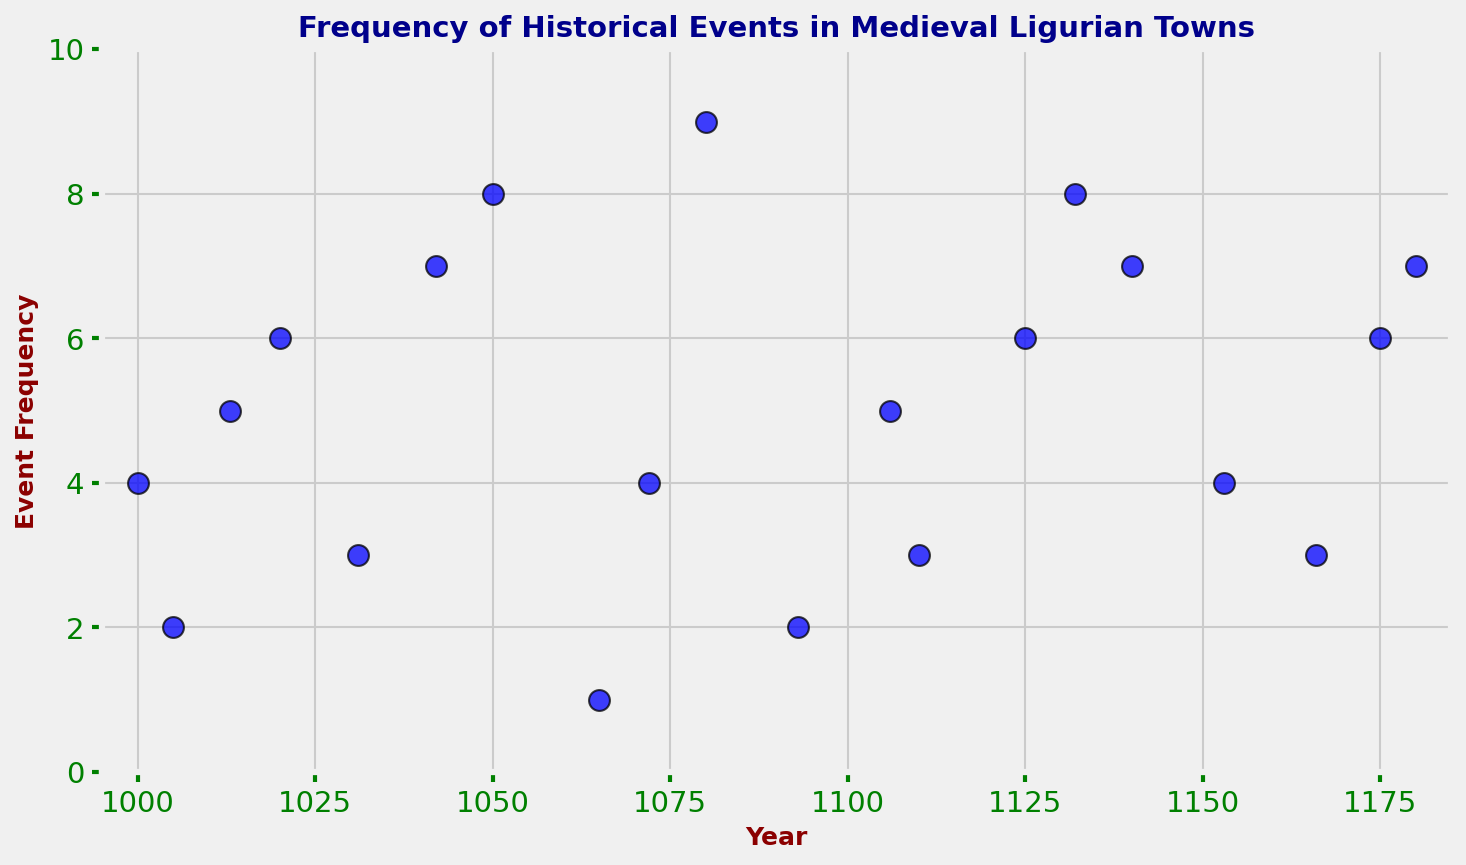What year has the highest frequency of historical events? In the scatter plot, look for the data point with the highest position on the y-axis. The highest frequency value is 9, which occurs in the year 1080.
Answer: 1080 Which year has the lowest number of historical events recorded? Identify the data point with the lowest y-axis value. The lowest frequency value is 1, which occurs in the year 1065.
Answer: 1065 What is the average frequency of historical events recorded over the entire period? Sum all the event frequencies and divide by the total number of years. (4 + 2 + 5 + 6 + 3 + 7 + 8 + 1 + 4 + 9 + 2 + 5 + 3 + 6 + 8 + 7 + 4 + 3 + 6 + 7) = 102. There are 20 years, so the average frequency is 102/20 = 5.1.
Answer: 5.1 How many years have an event frequency greater than 6? Count the number of years with a frequency greater than 6. The years are 1050, 1080, 1132, and 1180. There are 4 such years.
Answer: 4 Is there a year where the frequency of historical events is the same as the year 1050? Check if any other year has an event frequency of 8, as seen in 1050. The year 1132 also has a frequency of 8.
Answer: Yes What is the total frequency of historical events from the year 1100 to 1150? Sum the event frequencies within the specified year range: (1106: 5) + (1110: 3) + (1125: 6) + (1132: 8) + (1140: 7) = 5 + 3 + 6 + 8 + 7 = 29.
Answer: 29 Between the years 1000 and 1050, which year had the highest event frequency? From 1000 to 1050, the frequencies are as follows: (1000: 4), (1005: 2), (1013: 5), (1020: 6), (1031: 3), (1042: 7), (1050: 8). The highest frequency is 8 in 1050.
Answer: 1050 Between the years 1150 and 1180, which year had the lowest event frequency? From 1150 to 1180, the frequencies are as follows: (1153: 4), (1166: 3), (1175: 6), (1180: 7). The lowest frequency is 3 in 1166.
Answer: 1166 Are there any years where the event frequency is exactly 5? If so, list them. Look for years where the event frequency is 5. The years are 1013, 1106.
Answer: 1013, 1106 